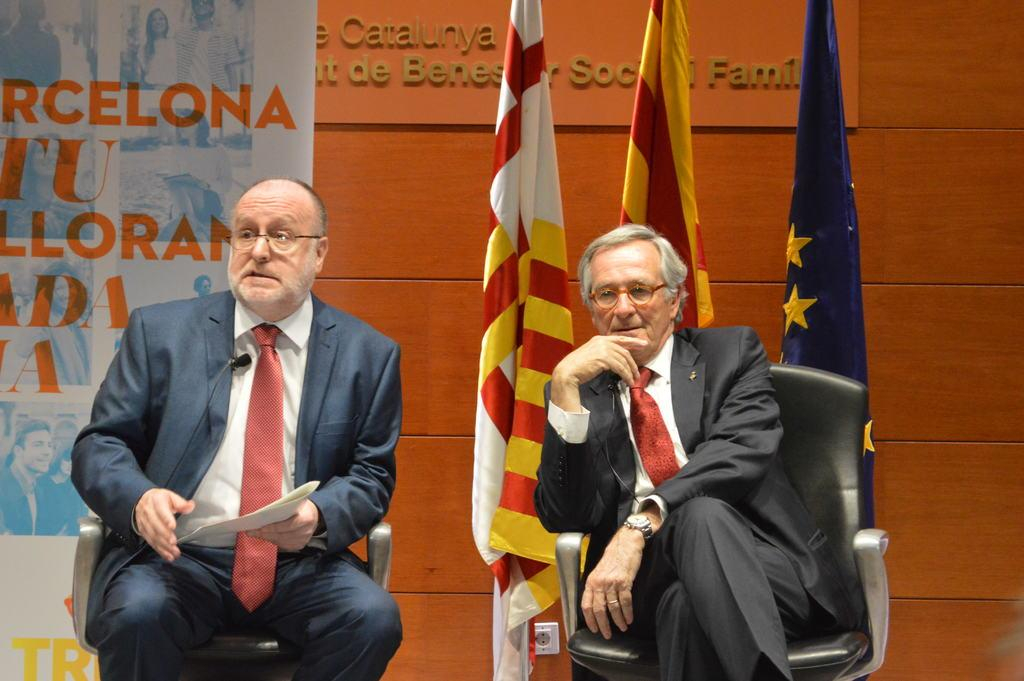How many people are sitting in the image? There are two people sitting in the image. What is the man on the left holding? The man on the left is holding papers. What can be seen in the background of the image? There are flags and a wall in the background of the image. What is the board visible in the image used for? It is not clear from the image what the board is used for. What is the purpose of the banner in the image? The purpose of the banner in the image is not clear from the provided facts. Reasoning: Let's think step by step by step in order to produce the conversation. We start by identifying the main subjects in the image, which are the two people sitting. Then, we describe the actions and objects associated with each person, such as the man holding papers. Next, we mention the background elements, including the flags and wall. Finally, we acknowledge the presence of the board and banner, but since their purpose is not clear from the provided facts, we do not speculate on their use. Absurd Question/Answer: What type of stone can be seen rolling down the slope in the image? There is no stone or slope present in the image. How is the powder being used in the image? There is no powder present in the image. 